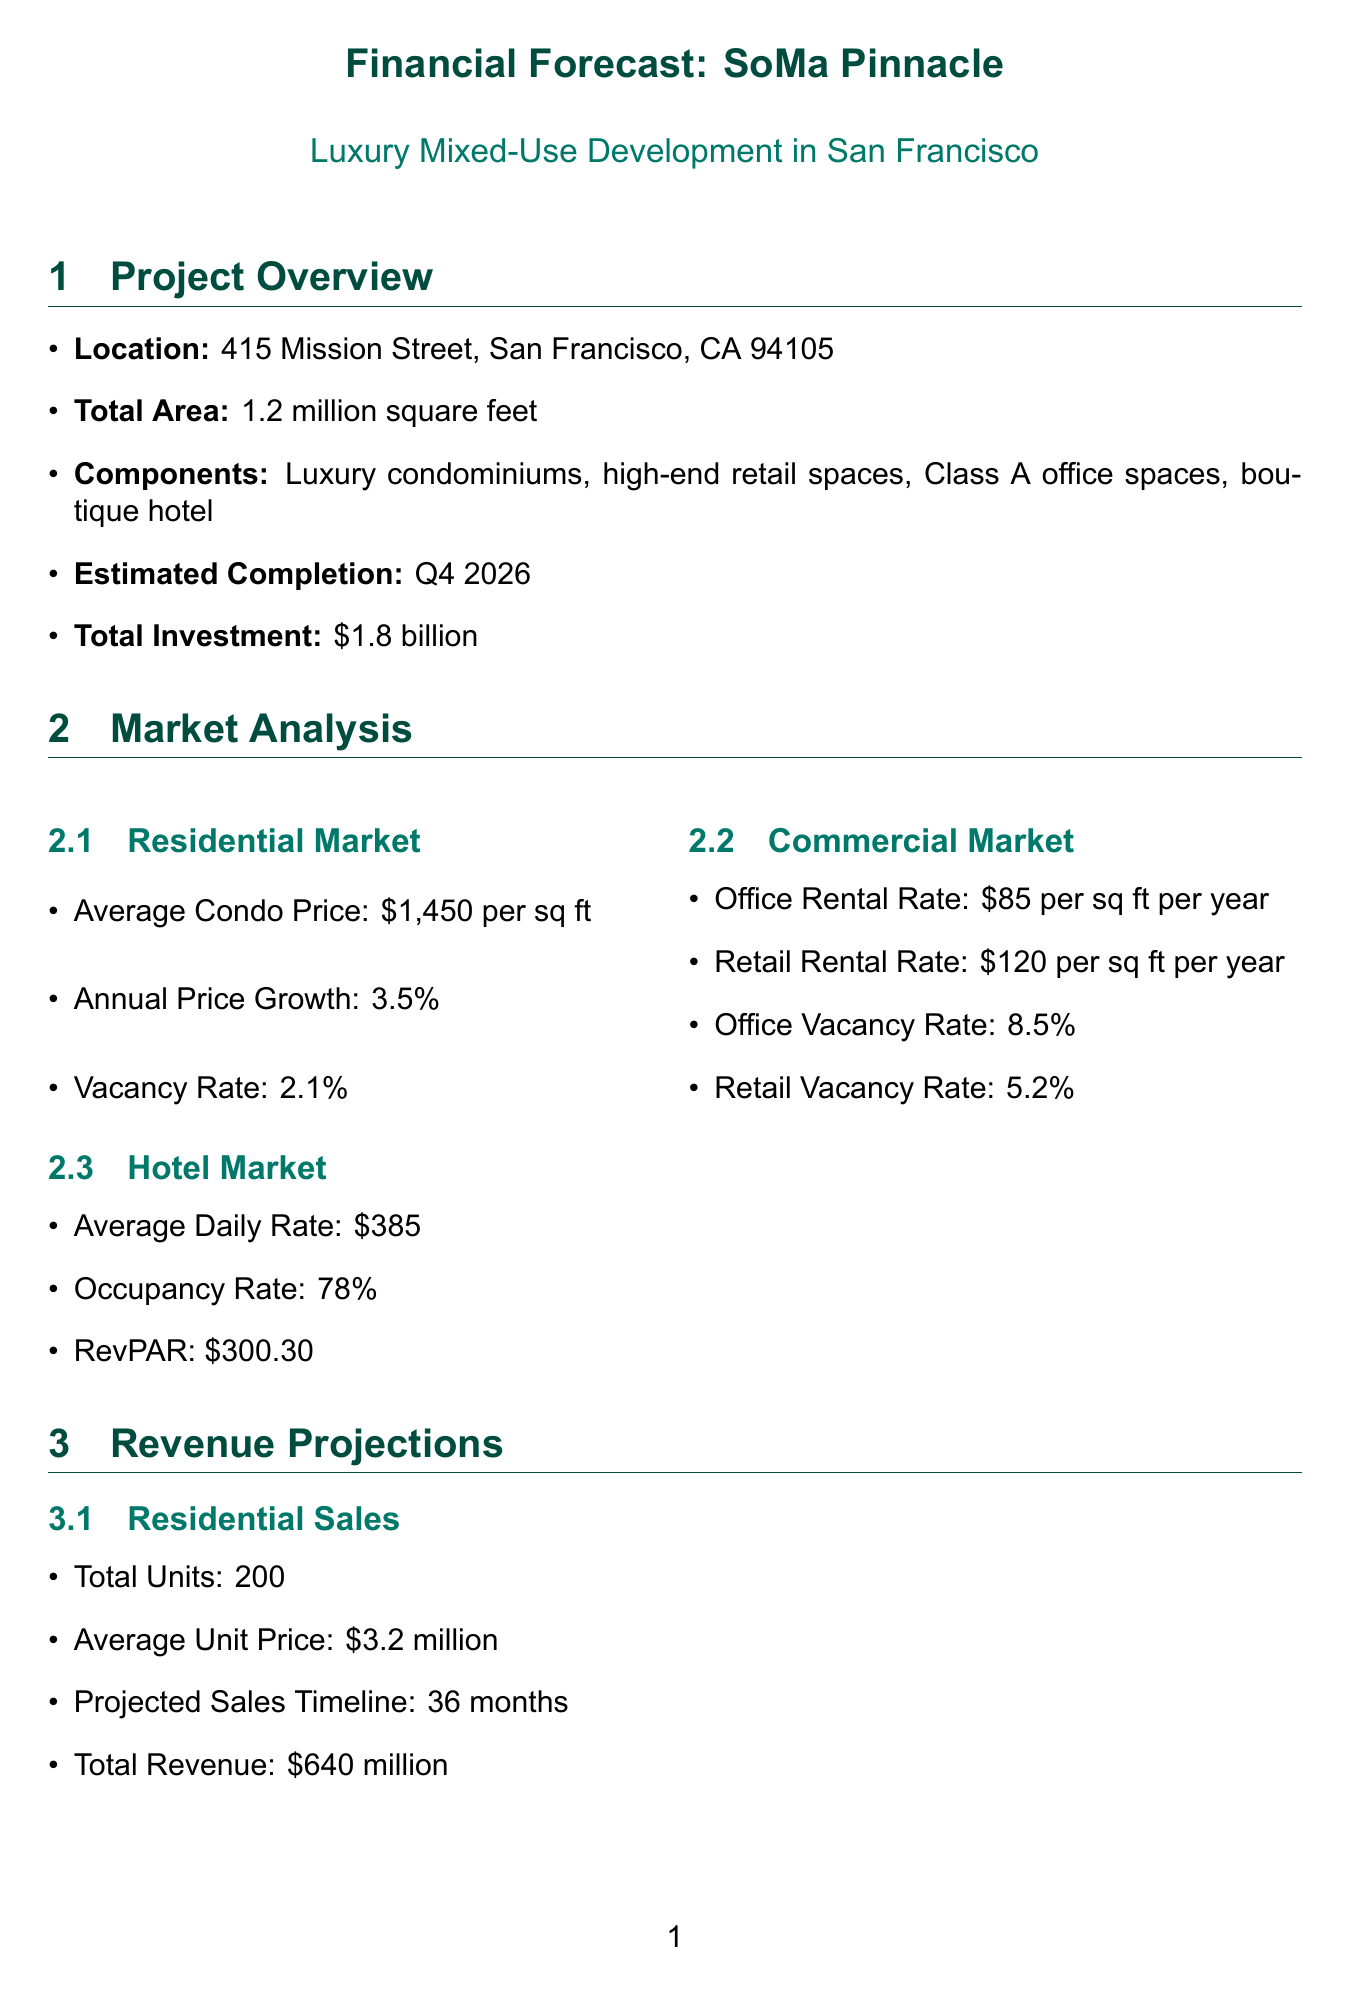What is the total investment? The total investment for the project "SoMa Pinnacle" is stated in the project overview section of the document.
Answer: $1.8 billion What is the average condo price? The average condo price can be found in the residential market analysis section of the document.
Answer: $1,450 per square foot What is the annual revenue from hotel operations? The document lists the annual revenue from hotel operations in the revenue projections section.
Answer: $28.5 million What is the projected sales timeline for residential units? The projected sales timeline is specified under the residential sales section of the revenue projections.
Answer: 36 months What is the internal rate of return? The internal rate of return is detailed in the financial projections section of the document.
Answer: 18.5% How many units will be sold in the residential market? The total number of residential units is found in the residential sales section of the revenue projections.
Answer: 200 What are the options outlined in the exit strategy? The exit strategy section lists various options, which include selling, refinancing, and partial sales.
Answer: Sell entire project, refinance, partial sale What is the total area of the development? The total area is clearly mentioned in the project overview section of the document.
Answer: 1.2 million square feet What is the financing cost? The financing cost is specified in the cost estimates section of the document.
Answer: $180 million 